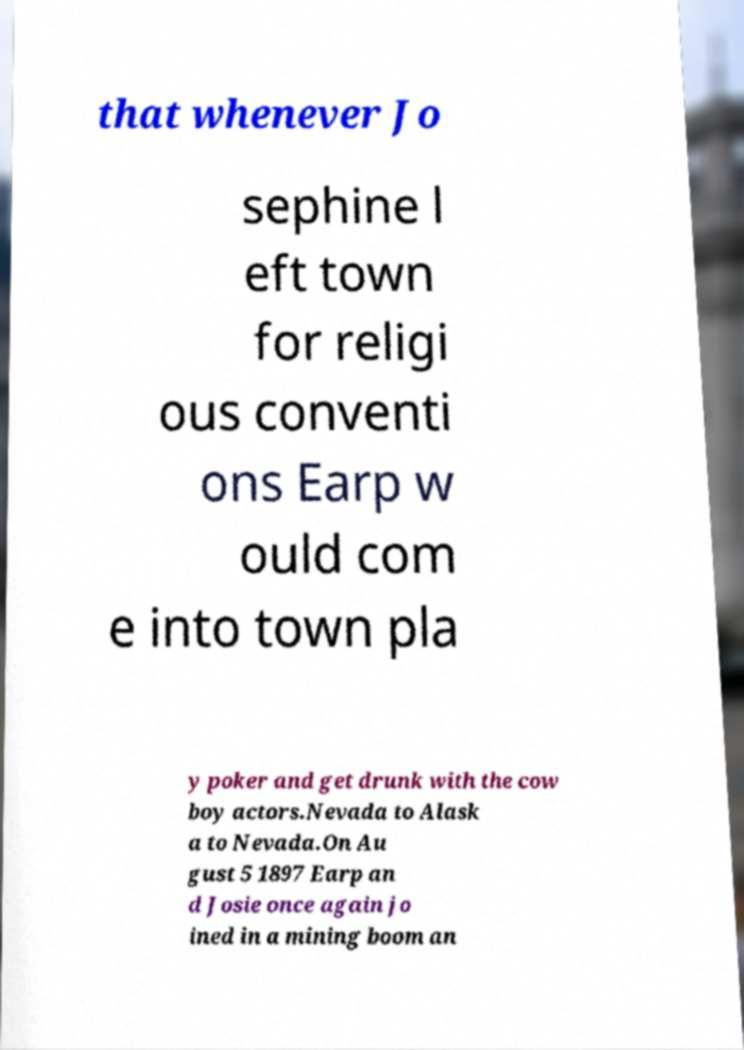Please identify and transcribe the text found in this image. that whenever Jo sephine l eft town for religi ous conventi ons Earp w ould com e into town pla y poker and get drunk with the cow boy actors.Nevada to Alask a to Nevada.On Au gust 5 1897 Earp an d Josie once again jo ined in a mining boom an 